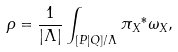<formula> <loc_0><loc_0><loc_500><loc_500>\rho = \frac { 1 } { | \Lambda | } \int _ { [ P | Q ] / \Lambda } { \pi _ { X } } ^ { \ast } \omega _ { X } ,</formula> 